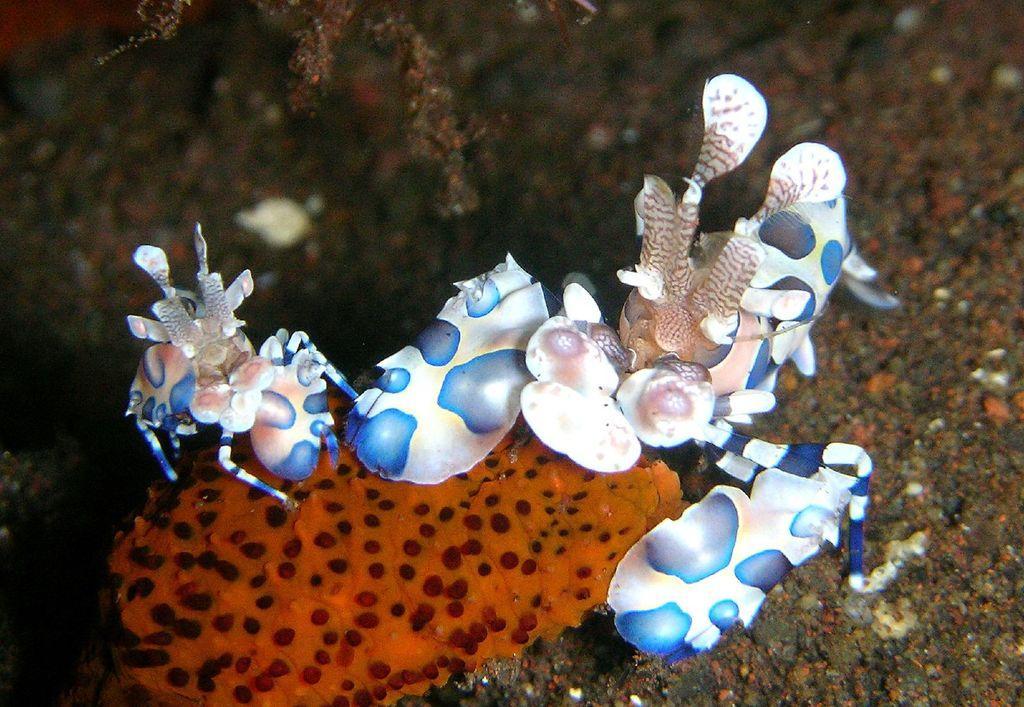Can you describe this image briefly? In this picture we can observe white color shells in the water. We can observe an orange color shell. We can observe a plant hire. The background is blurred. 